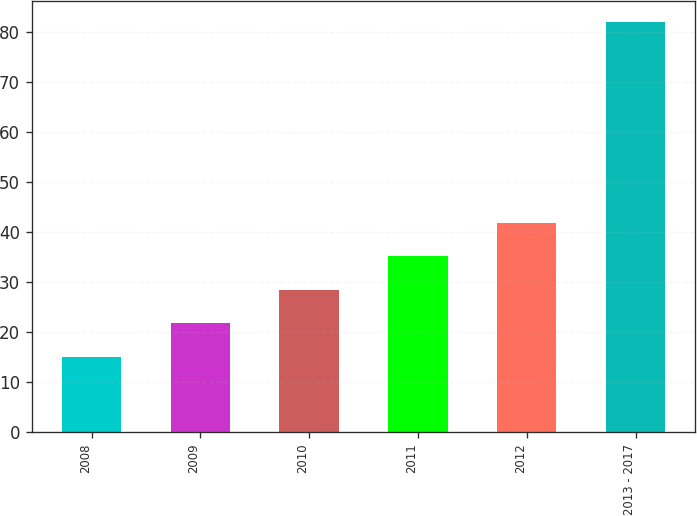<chart> <loc_0><loc_0><loc_500><loc_500><bar_chart><fcel>2008<fcel>2009<fcel>2010<fcel>2011<fcel>2012<fcel>2013 - 2017<nl><fcel>15<fcel>21.7<fcel>28.4<fcel>35.1<fcel>41.8<fcel>82<nl></chart> 